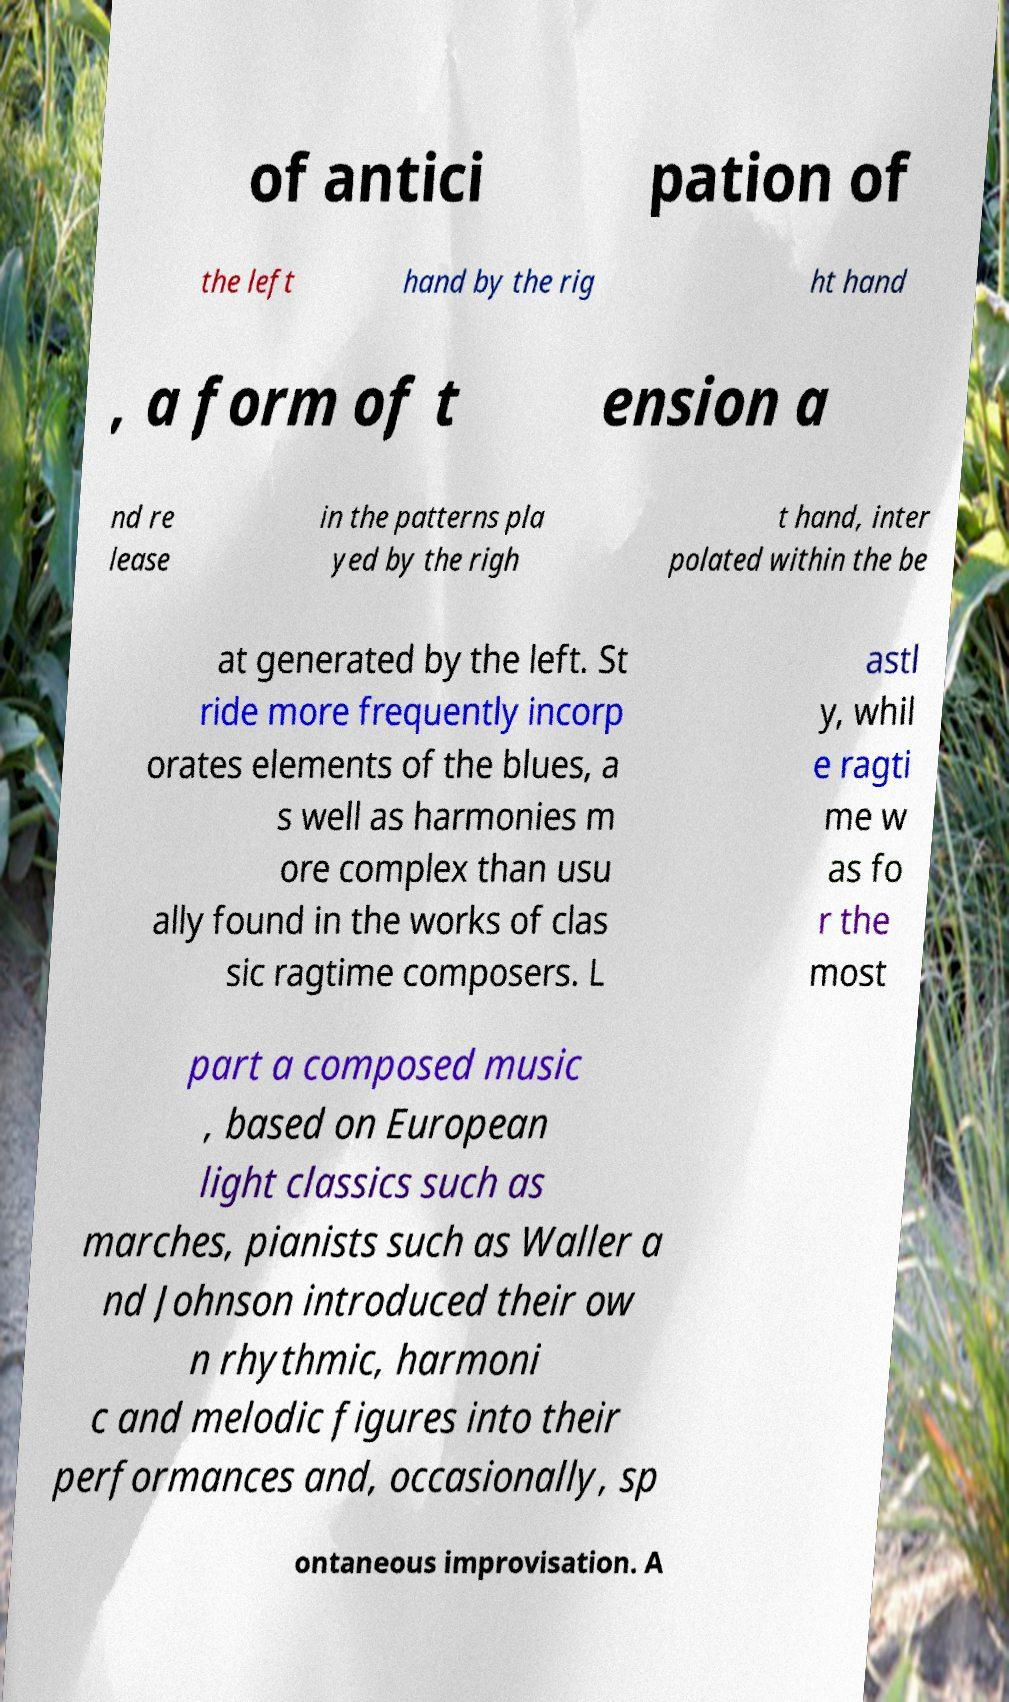There's text embedded in this image that I need extracted. Can you transcribe it verbatim? of antici pation of the left hand by the rig ht hand , a form of t ension a nd re lease in the patterns pla yed by the righ t hand, inter polated within the be at generated by the left. St ride more frequently incorp orates elements of the blues, a s well as harmonies m ore complex than usu ally found in the works of clas sic ragtime composers. L astl y, whil e ragti me w as fo r the most part a composed music , based on European light classics such as marches, pianists such as Waller a nd Johnson introduced their ow n rhythmic, harmoni c and melodic figures into their performances and, occasionally, sp ontaneous improvisation. A 